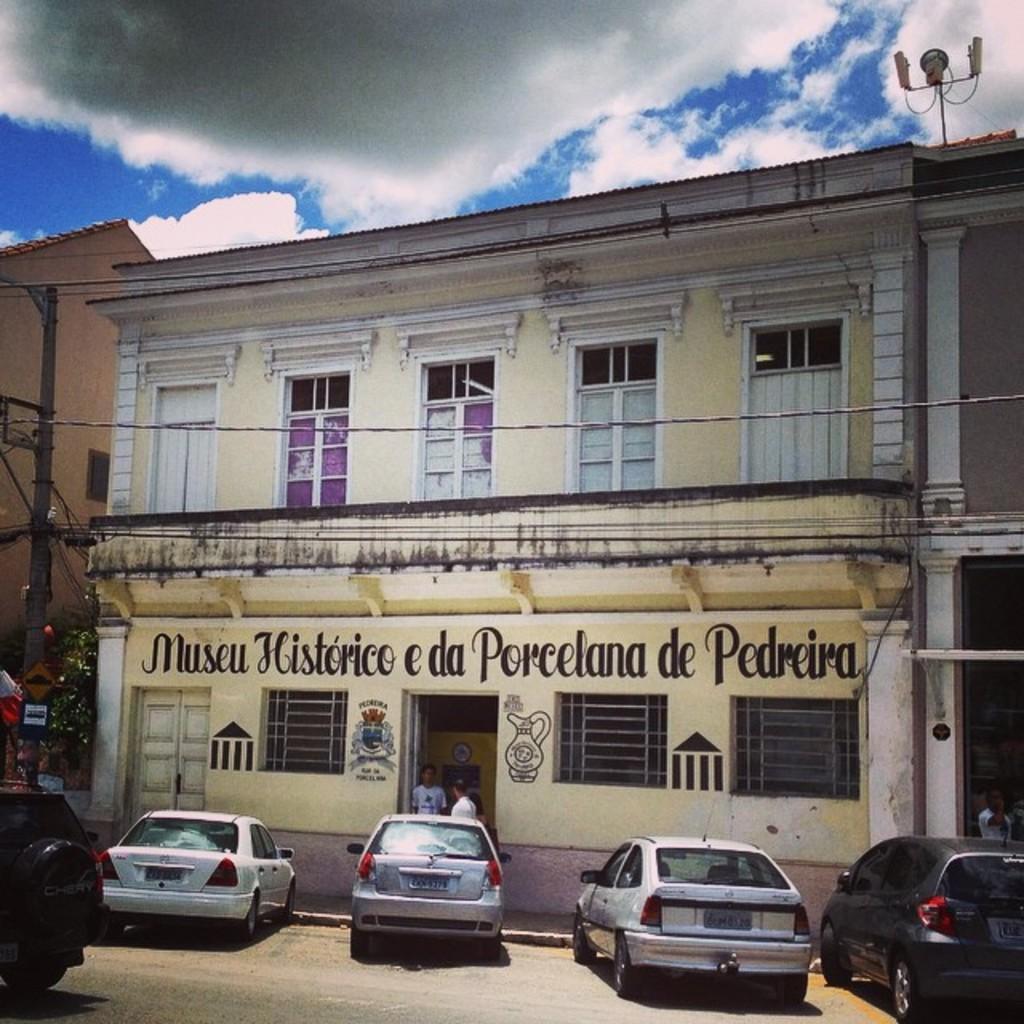In one or two sentences, can you explain what this image depicts? At the bottom of the image we can see some vehicles on the road. Behind the vehicles few people are standing and there are some trees, poles and buildings. At the top of the image there are some clouds in the sky. 